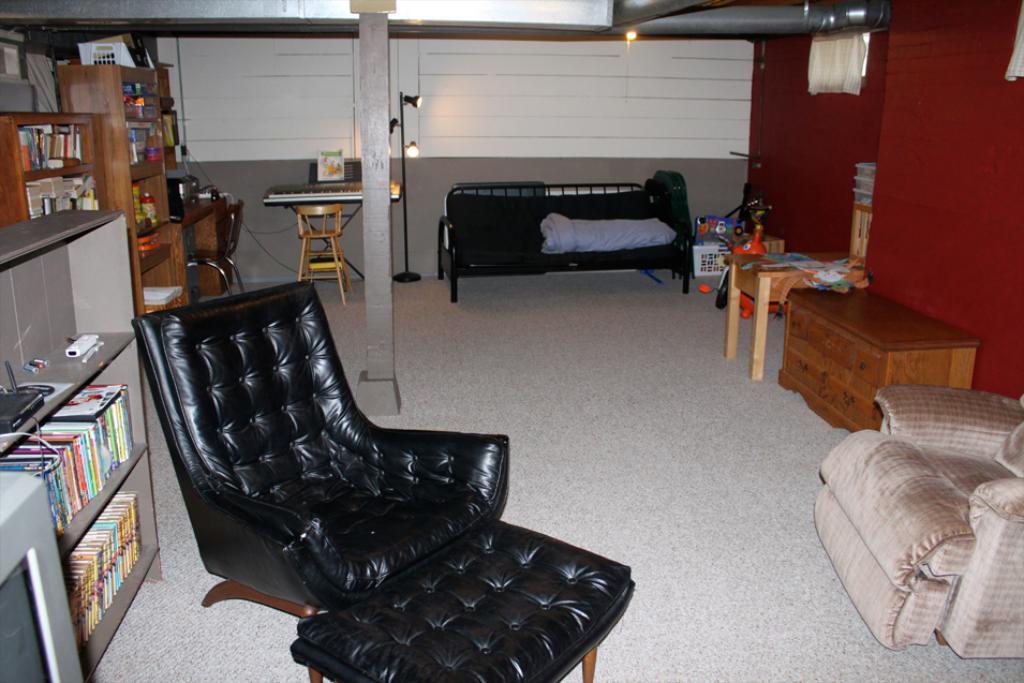How would you summarize this image in a sentence or two? This is a picture taken in a room, this is a floor on the floor there are tables, chairs , sofa, pillar. To the left side of the chair there are shelves with books and some items. To the right side of the chair there is a red wall. Behind the chair there is a lights with stand and a wall. 